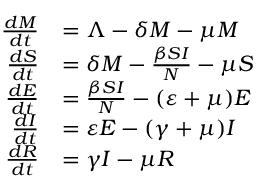<formula> <loc_0><loc_0><loc_500><loc_500>{ \begin{array} { r l } { { \frac { d M } { d t } } } & { = \Lambda - \delta M - \mu M } \\ { { \frac { d S } { d t } } } & { = \delta M - { \frac { \beta S I } { N } } - \mu S } \\ { { \frac { d E } { d t } } } & { = { \frac { \beta S I } { N } } - ( \varepsilon + \mu ) E } \\ { { \frac { d I } { d t } } } & { = \varepsilon E - ( \gamma + \mu ) I } \\ { { \frac { d R } { d t } } } & { = \gamma I - \mu R } \end{array} }</formula> 